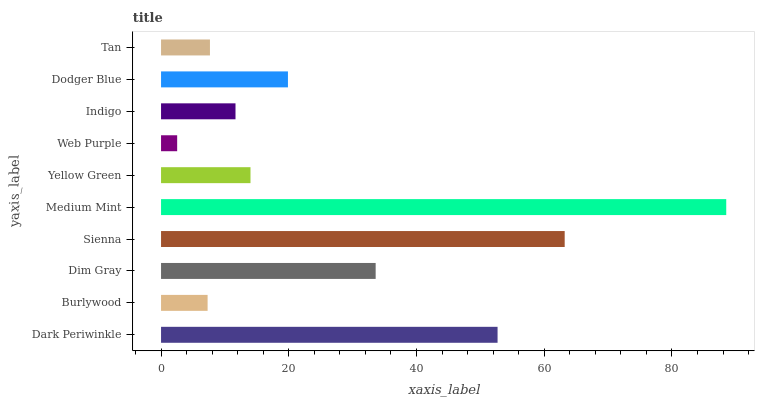Is Web Purple the minimum?
Answer yes or no. Yes. Is Medium Mint the maximum?
Answer yes or no. Yes. Is Burlywood the minimum?
Answer yes or no. No. Is Burlywood the maximum?
Answer yes or no. No. Is Dark Periwinkle greater than Burlywood?
Answer yes or no. Yes. Is Burlywood less than Dark Periwinkle?
Answer yes or no. Yes. Is Burlywood greater than Dark Periwinkle?
Answer yes or no. No. Is Dark Periwinkle less than Burlywood?
Answer yes or no. No. Is Dodger Blue the high median?
Answer yes or no. Yes. Is Yellow Green the low median?
Answer yes or no. Yes. Is Yellow Green the high median?
Answer yes or no. No. Is Dark Periwinkle the low median?
Answer yes or no. No. 